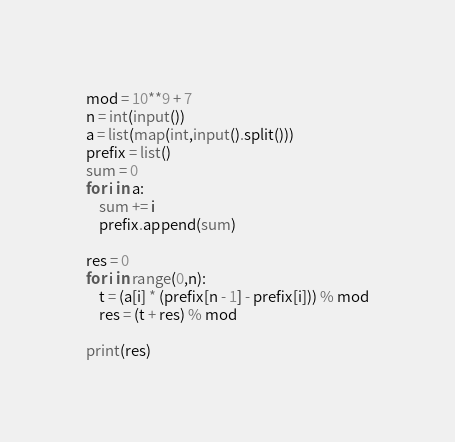Convert code to text. <code><loc_0><loc_0><loc_500><loc_500><_Python_>mod = 10**9 + 7
n = int(input())
a = list(map(int,input().split()))
prefix = list()
sum = 0
for i in a:
	sum += i
	prefix.append(sum)

res = 0
for i in range(0,n):
	t = (a[i] * (prefix[n - 1] - prefix[i])) % mod
	res = (t + res) % mod

print(res)</code> 